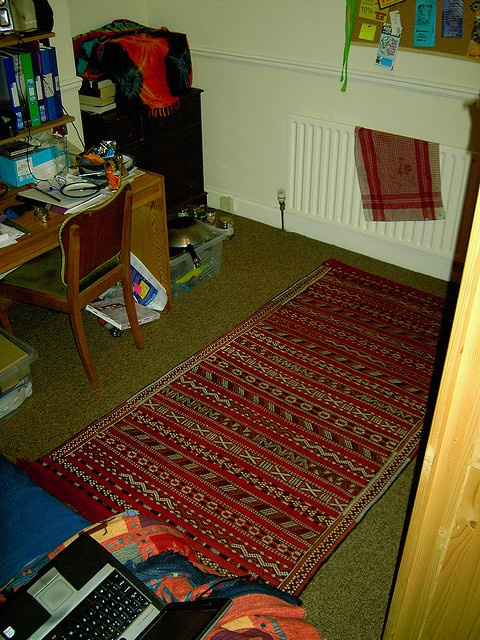Describe the objects in this image and their specific colors. I can see bed in gray, black, navy, and brown tones, laptop in gray, black, and darkgray tones, chair in gray, black, maroon, and olive tones, book in gray, maroon, black, and darkgreen tones, and book in gray, darkgray, olive, and lightgray tones in this image. 